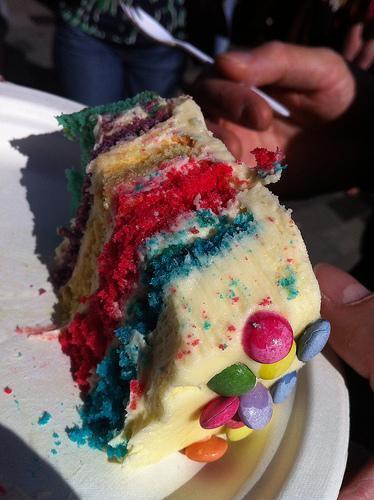How many forks are shown?
Give a very brief answer. 1. 